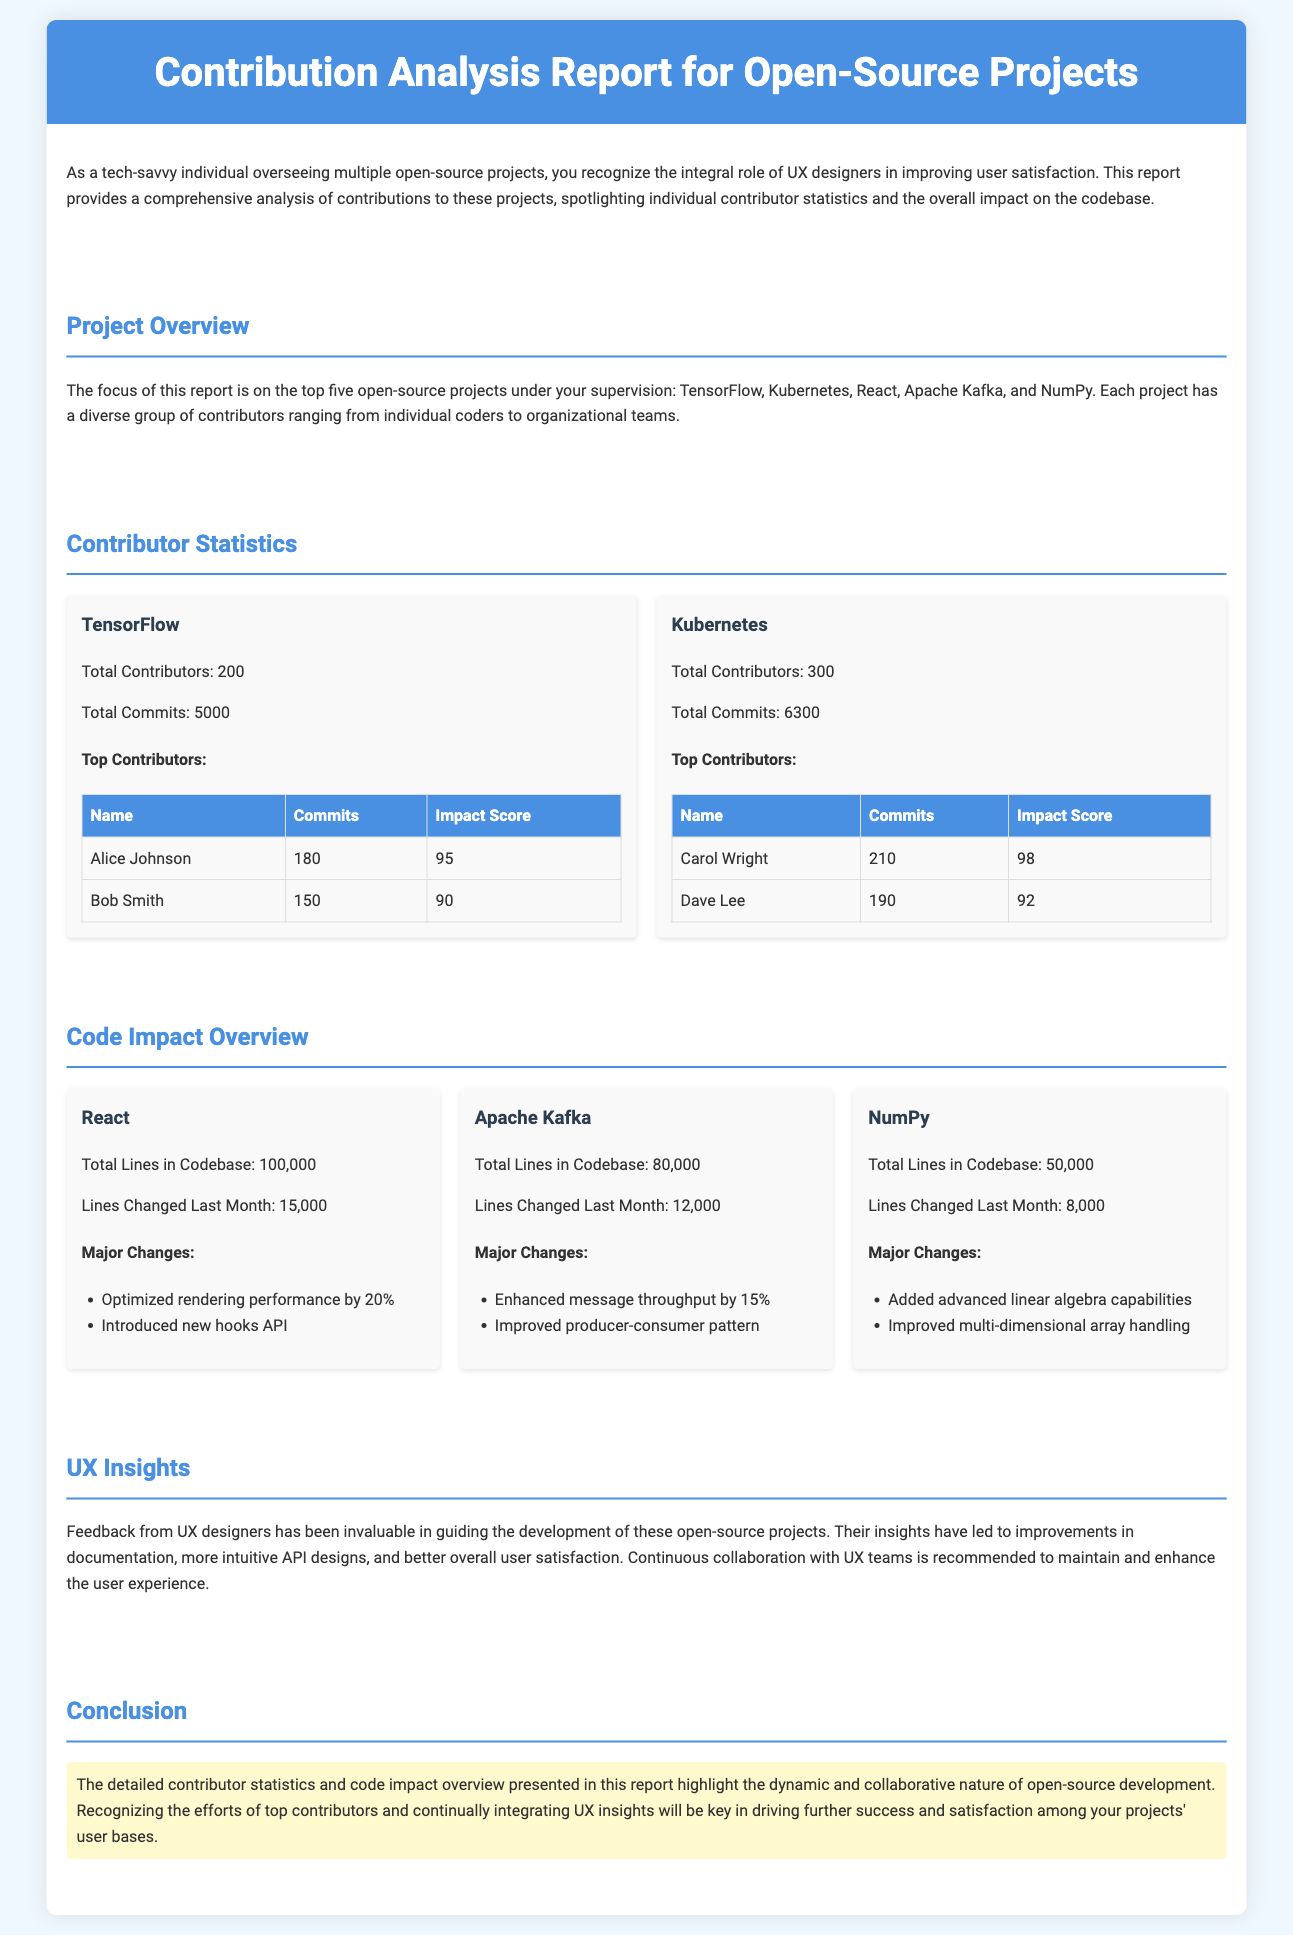What is the total number of contributors for Kubernetes? The total number of contributors for Kubernetes is provided in the contributor statistics section of the report.
Answer: 300 Who are the top contributors for TensorFlow? The report lists the names of the top contributors for TensorFlow in the contributor statistics section.
Answer: Alice Johnson, Bob Smith What is the total number of commits for Apache Kafka? The total number of commits for Apache Kafka is mentioned in the contributor statistics section.
Answer: 6300 How many lines were changed last month in React? The document specifies the number of lines changed last month for each project, including React.
Answer: 15,000 What major change was introduced in NumPy? The major changes for each project are listed, including what was introduced in NumPy.
Answer: Added advanced linear algebra capabilities Which project has the highest impact score contributor? The impact scores for the top contributors are mentioned in the contributor statistics section, allowing comparison.
Answer: Kubernetes What feedback has been valuable for guiding development? The report mentions specific input gathered from a particular group that has influenced project development.
Answer: UX designers What is the total number of lines in the codebase for NumPy? The total lines in the codebase for each project are explicitly stated in the document.
Answer: 50,000 